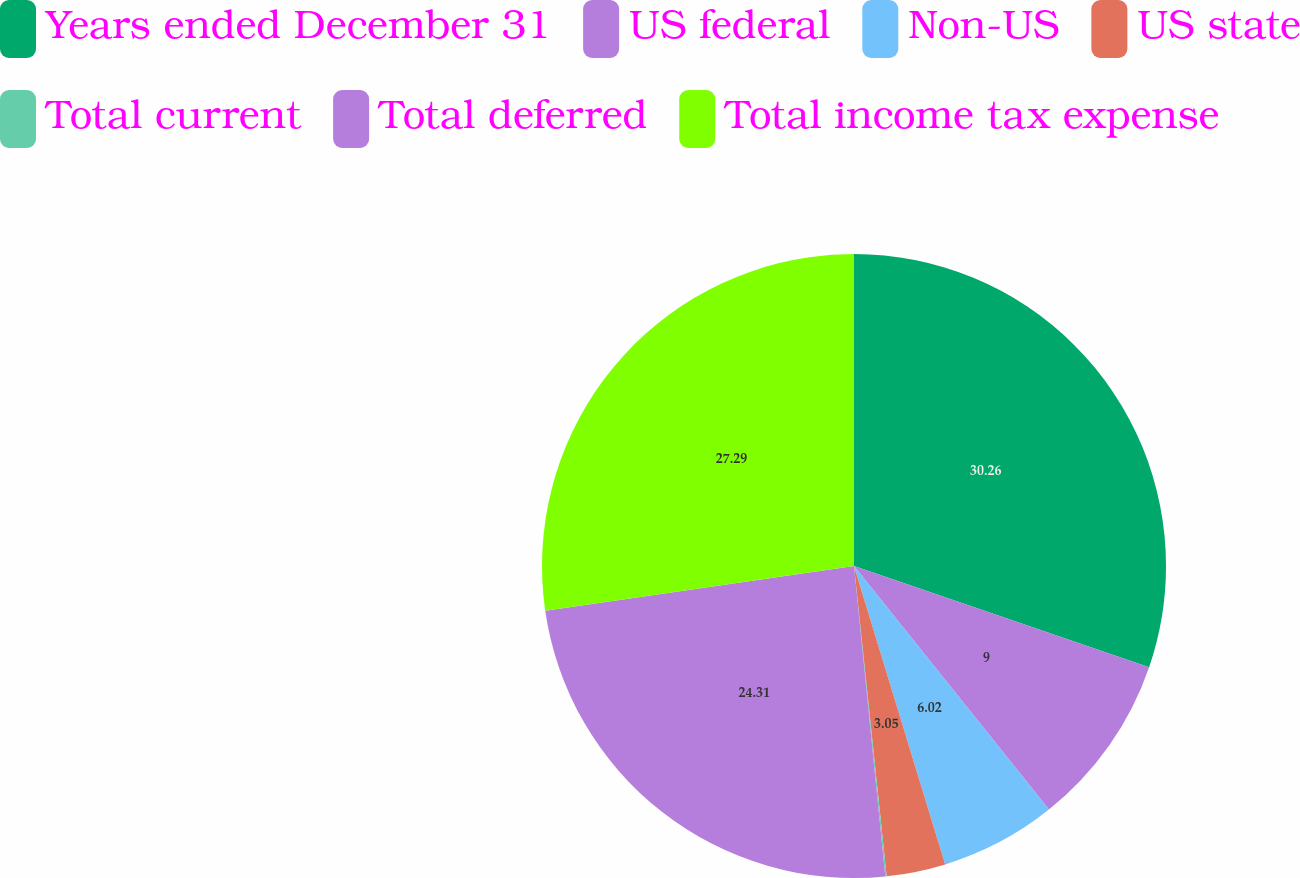Convert chart. <chart><loc_0><loc_0><loc_500><loc_500><pie_chart><fcel>Years ended December 31<fcel>US federal<fcel>Non-US<fcel>US state<fcel>Total current<fcel>Total deferred<fcel>Total income tax expense<nl><fcel>30.26%<fcel>9.0%<fcel>6.02%<fcel>3.05%<fcel>0.07%<fcel>24.31%<fcel>27.29%<nl></chart> 